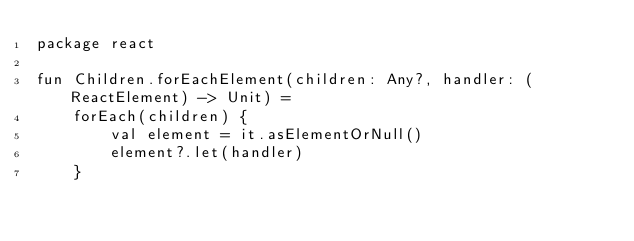<code> <loc_0><loc_0><loc_500><loc_500><_Kotlin_>package react

fun Children.forEachElement(children: Any?, handler: (ReactElement) -> Unit) =
    forEach(children) {
        val element = it.asElementOrNull()
        element?.let(handler)
    }
</code> 